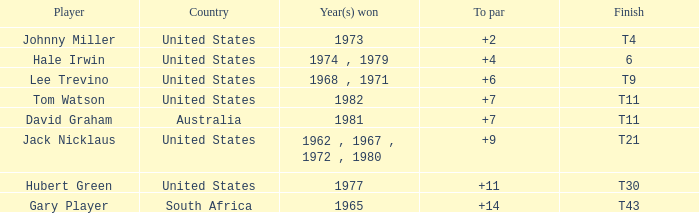WHAT IS THE TOTAL, OF A TO PAR FOR HUBERT GREEN, AND A TOTAL LARGER THAN 291? 0.0. 